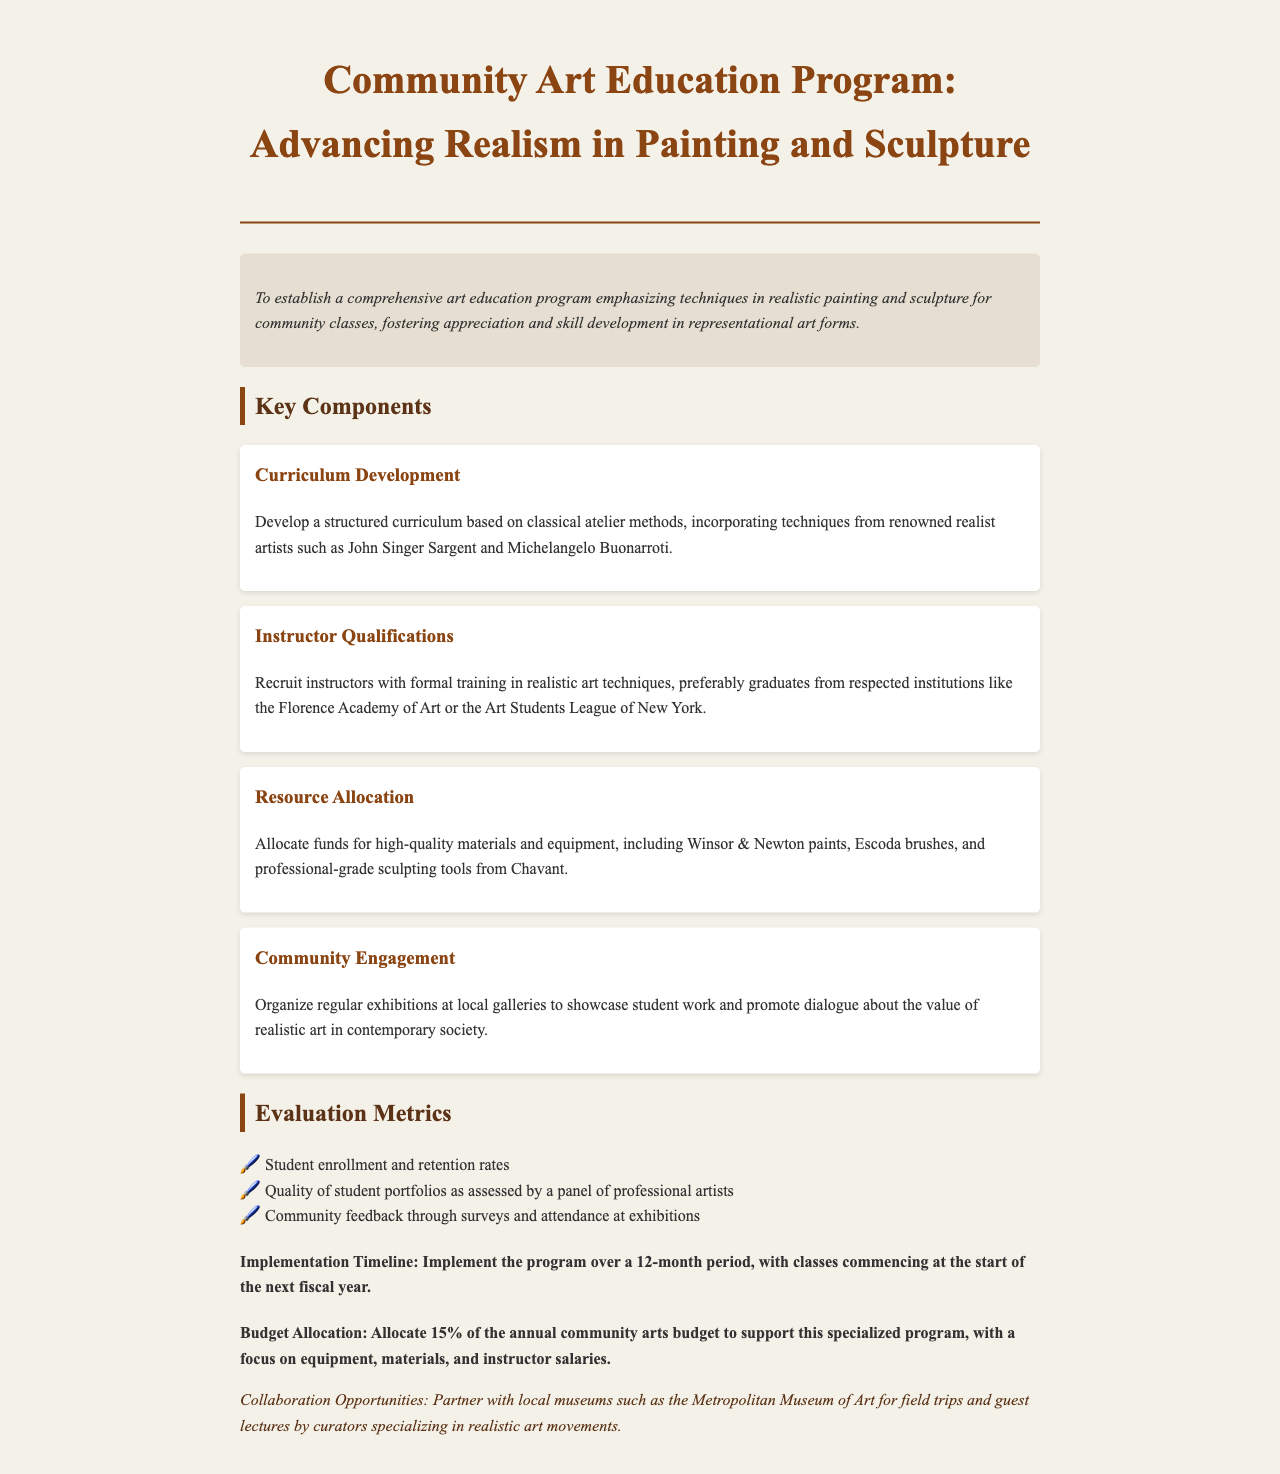What is the primary objective of the program? The primary objective is to establish a comprehensive art education program emphasizing techniques in realistic painting and sculpture for community classes.
Answer: To establish a comprehensive art education program emphasizing techniques in realistic painting and sculpture for community classes Who should the instructors be recruited from? Instructors should preferably be graduates from respected institutions like the Florence Academy of Art or the Art Students League of New York.
Answer: Respected institutions like the Florence Academy of Art or the Art Students League of New York What percentage of the annual community arts budget is allocated to this program? The document specifies that 15% of the annual community arts budget is allocated to support this specialized program.
Answer: 15% Which renowned artist is mentioned in the curriculum development section? The curriculum development section mentions John Singer Sargent as a renowned realist artist.
Answer: John Singer Sargent What are the evaluation metrics used in the program? The evaluation metrics include student enrollment and retention rates, quality of student portfolios, and community feedback.
Answer: Student enrollment and retention rates, quality of student portfolios, community feedback How long is the implementation timeline for the program? The implementation timeline for the program is 12 months, with classes commencing at the start of the next fiscal year.
Answer: 12 months What type of materials will the program allocate funds for? The program will allocate funds for high-quality materials and equipment, including Winsor & Newton paints and professional-grade sculpting tools.
Answer: High-quality materials and equipment, including Winsor & Newton paints and professional-grade sculpting tools What is the purpose of organizing regular exhibitions? The purpose is to showcase student work and promote dialogue about the value of realistic art in contemporary society.
Answer: To showcase student work and promote dialogue about the value of realistic art in contemporary society 